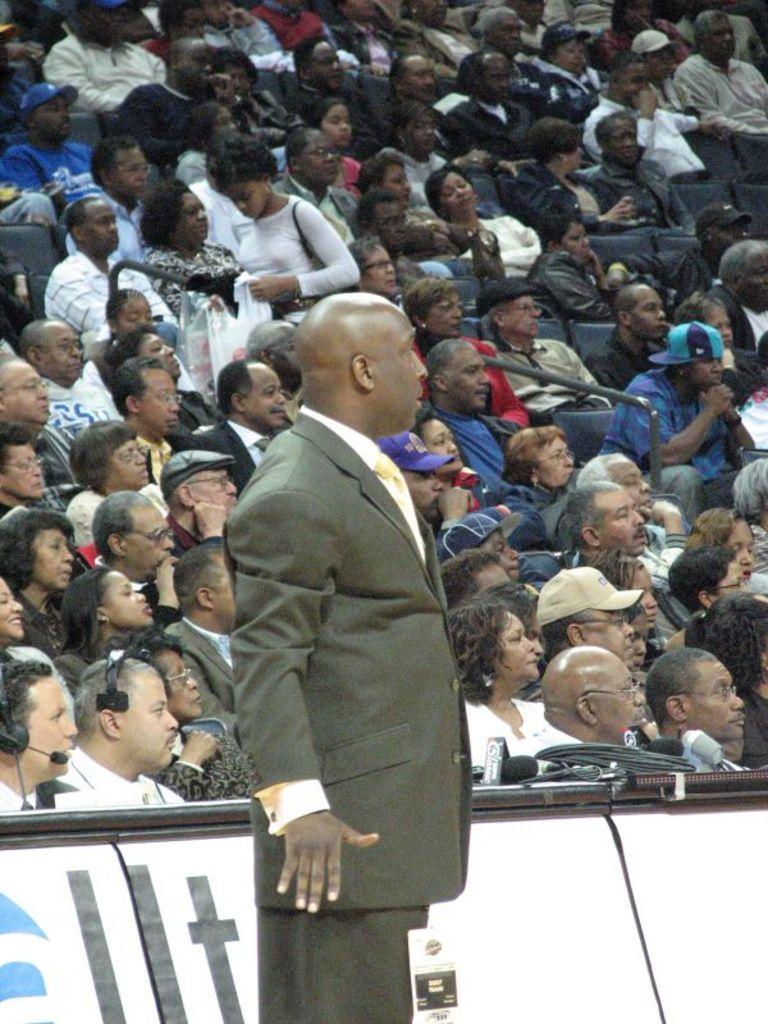Describe this image in one or two sentences. In this picture there is a man standing and we can see microphones and objects on tables. In the background of the image these are audience. 